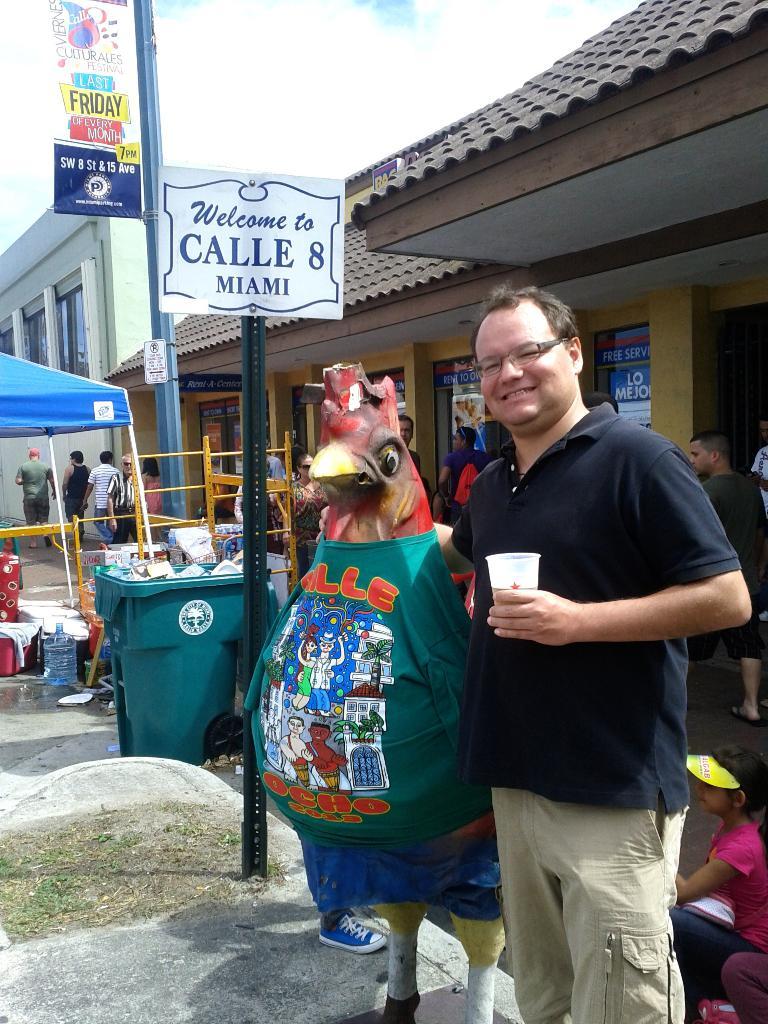What city is this in?
Keep it short and to the point. Miami. 